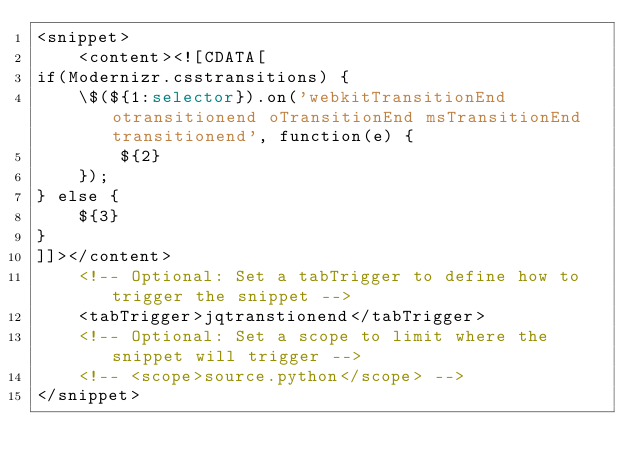Convert code to text. <code><loc_0><loc_0><loc_500><loc_500><_XML_><snippet>
	<content><![CDATA[
if(Modernizr.csstransitions) {
	\$(${1:selector}).on('webkitTransitionEnd otransitionend oTransitionEnd msTransitionEnd transitionend', function(e) {
		${2}
	});
} else {
	${3}
}
]]></content>
	<!-- Optional: Set a tabTrigger to define how to trigger the snippet -->
	<tabTrigger>jqtranstionend</tabTrigger>
	<!-- Optional: Set a scope to limit where the snippet will trigger -->
	<!-- <scope>source.python</scope> -->
</snippet>
</code> 